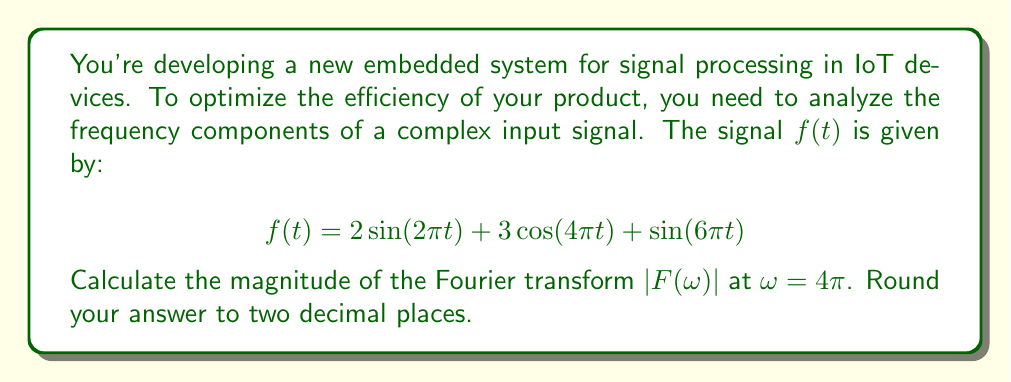Could you help me with this problem? To solve this problem, we'll follow these steps:

1) The Fourier transform of a sinusoidal function is given by:
   
   $$\mathcal{F}\{A\sin(\omega_0 t)\} = \frac{Ai}{2}[\delta(\omega-\omega_0) - \delta(\omega+\omega_0)]$$
   $$\mathcal{F}\{A\cos(\omega_0 t)\} = \frac{A}{2}[\delta(\omega-\omega_0) + \delta(\omega+\omega_0)]$$

2) Our signal has three components:
   - $2\sin(2\pi t)$
   - $3\cos(4\pi t)$
   - $\sin(6\pi t)$

3) Let's transform each component:
   
   $$\mathcal{F}\{2\sin(2\pi t)\} = i[\delta(\omega-2\pi) - \delta(\omega+2\pi)]$$
   $$\mathcal{F}\{3\cos(4\pi t)\} = \frac{3}{2}[\delta(\omega-4\pi) + \delta(\omega+4\pi)]$$
   $$\mathcal{F}\{\sin(6\pi t)\} = \frac{i}{2}[\delta(\omega-6\pi) - \delta(\omega+6\pi)]$$

4) The total Fourier transform is the sum of these components:

   $$F(\omega) = i[\delta(\omega-2\pi) - \delta(\omega+2\pi)] + \frac{3}{2}[\delta(\omega-4\pi) + \delta(\omega+4\pi)] + \frac{i}{2}[\delta(\omega-6\pi) - \delta(\omega+6\pi)]$$

5) We're asked to find $|F(\omega)|$ at $\omega = 4\pi$. At this frequency, only the second term is non-zero:

   $$F(4\pi) = \frac{3}{2}$$

6) The magnitude of this complex number is simply its absolute value:

   $$|F(4\pi)| = |\frac{3}{2}| = 1.5$$

7) Rounding to two decimal places gives 1.50.
Answer: 1.50 